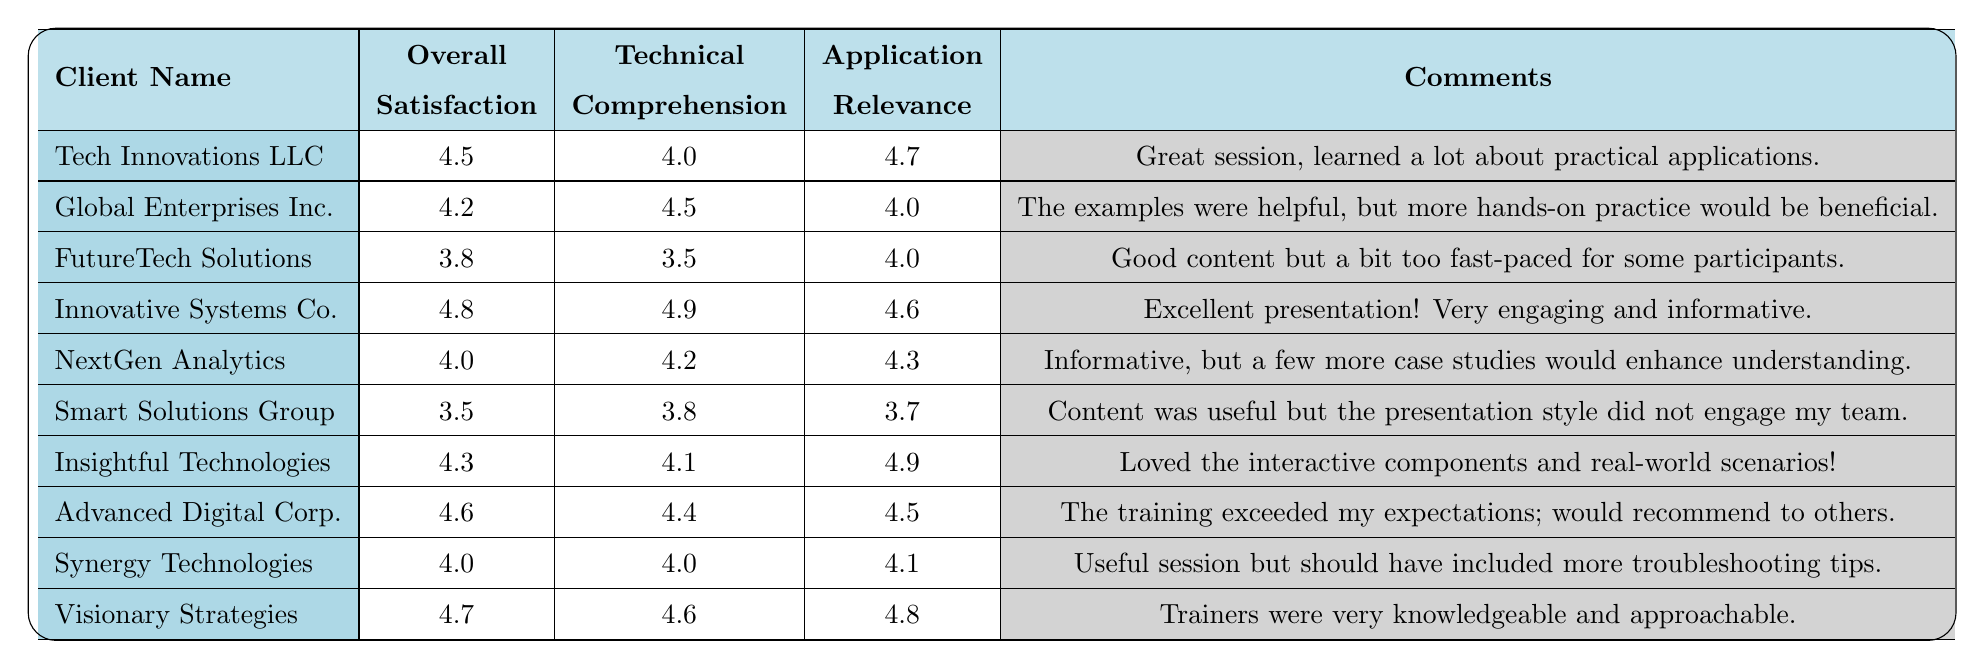What is the overall satisfaction score of Innovative Systems Co.? Looking at the row for Innovative Systems Co., the overall satisfaction score is listed as 4.8.
Answer: 4.8 Which client had the highest technical comprehension score? By reviewing the technical comprehension scores, Innovative Systems Co. has the highest score of 4.9.
Answer: 4.9 What is the average application relevance score for all clients? To calculate the average application relevance score, sum all the scores: (4.7 + 4.0 + 4.0 + 4.6 + 4.3 + 3.7 + 4.9 + 4.5 + 4.1 + 4.8) = 44.6. We have 10 clients, so the average is 44.6 / 10 = 4.46.
Answer: 4.46 Did Smart Solutions Group have an overall satisfaction score of at least 4.0? The overall satisfaction score for Smart Solutions Group is 3.5, which is less than 4.0. Therefore, the statement is false.
Answer: No How many clients rated their overall satisfaction above 4.5? The clients that rated their overall satisfaction above 4.5 are Tech Innovations LLC, Innovative Systems Co., Advanced Digital Corp., and Visionary Strategies. This totals 4 clients.
Answer: 4 For which client was the feedback regarding relevance of applications the lowest? Examining the application relevance scores, Smart Solutions Group has the lowest score at 3.7, indicating less relevance perceived.
Answer: Smart Solutions Group What percentage of clients found the training informative, with an overall satisfaction score above 4.0? The clients with scores above 4.0 are Tech Innovations LLC, Global Enterprises Inc., Innovative Systems Co., NextGen Analytics, Insightful Technologies, Advanced Digital Corp., Synergy Technologies, and Visionary Strategies, totaling 8 clients out of 10. Hence, the percentage is (8 / 10) * 100 = 80%.
Answer: 80% Which client provided comments indicating a need for more hands-on practice? From the feedback comments, Global Enterprises Inc. expressed that more hands-on practice would be beneficial.
Answer: Global Enterprises Inc What is the median overall satisfaction score among the clients? The overall satisfaction scores sorted in ascending order are: 3.5, 3.8, 4.0, 4.0, 4.2, 4.3, 4.5, 4.6, 4.7, 4.8. With 10 clients, the median is calculated as the average of the 5th and 6th scores: (4.2 + 4.3) / 2 = 4.25.
Answer: 4.25 